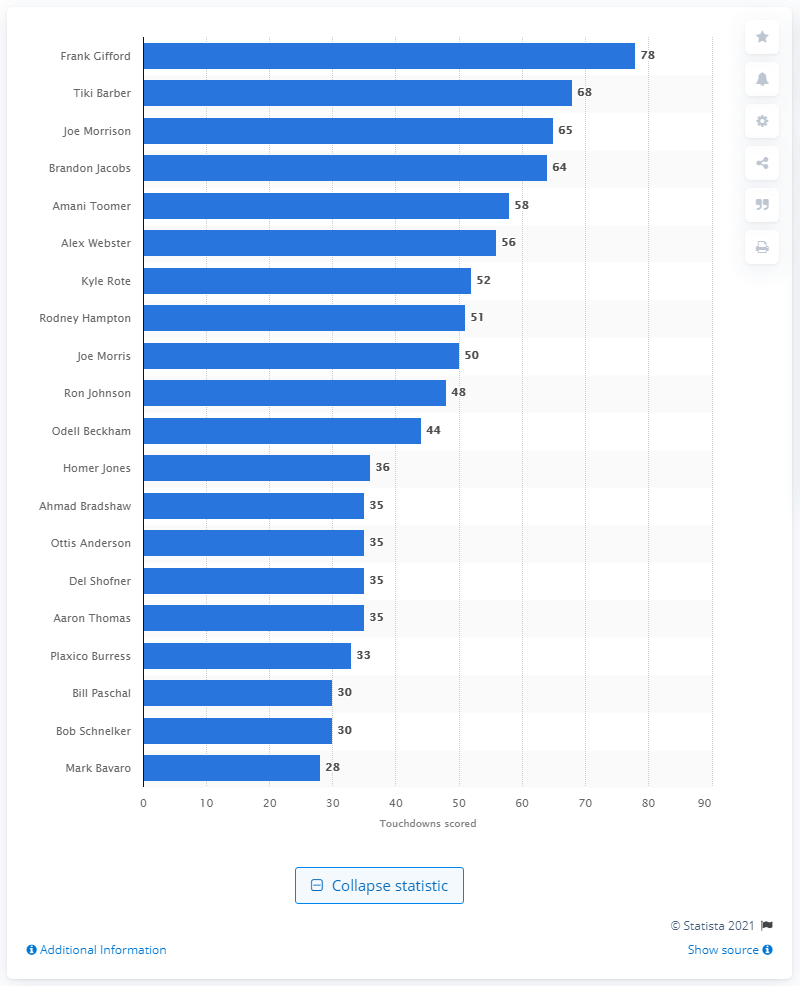Point out several critical features in this image. The career touchdown leader of the New York Giants is Frank Gifford. 